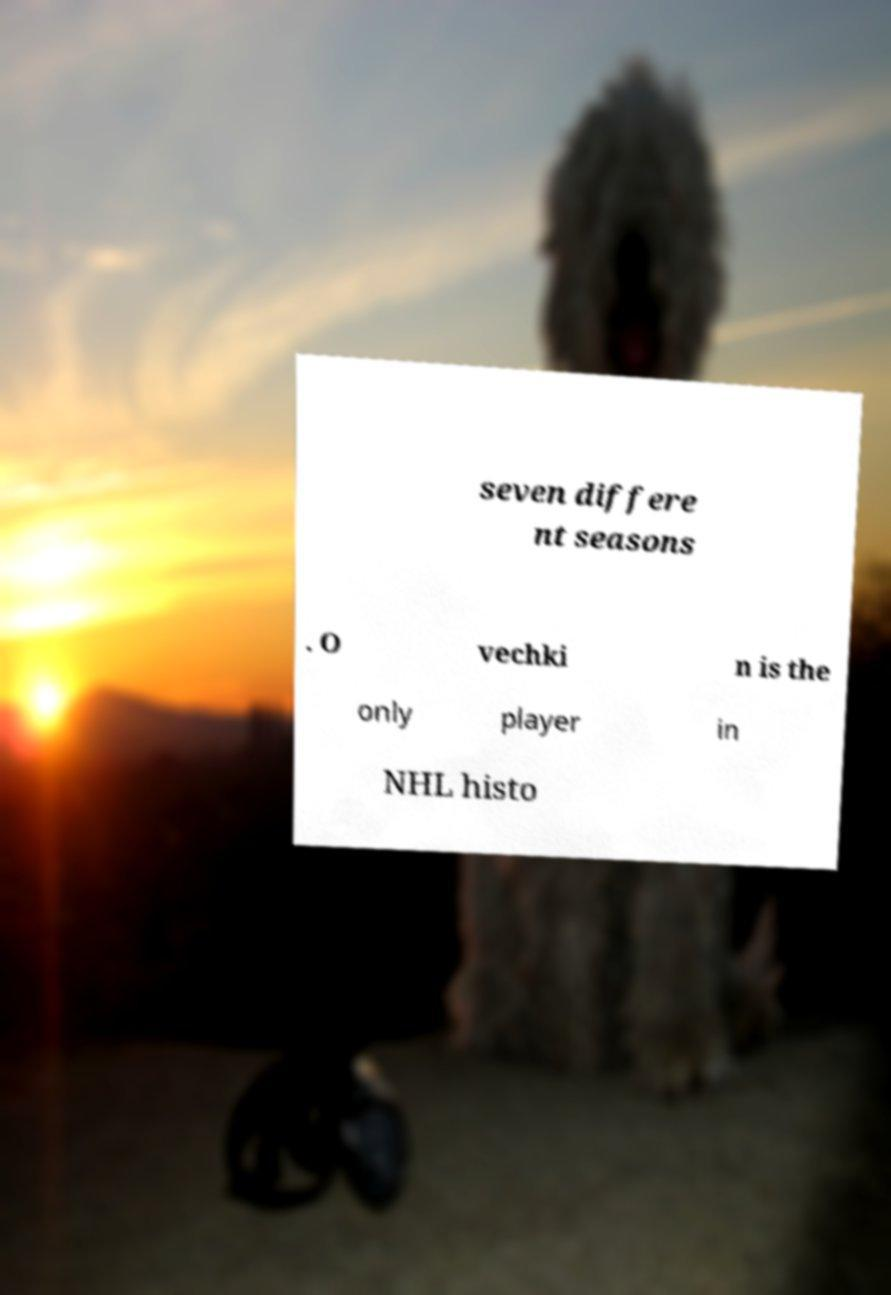Please identify and transcribe the text found in this image. seven differe nt seasons . O vechki n is the only player in NHL histo 